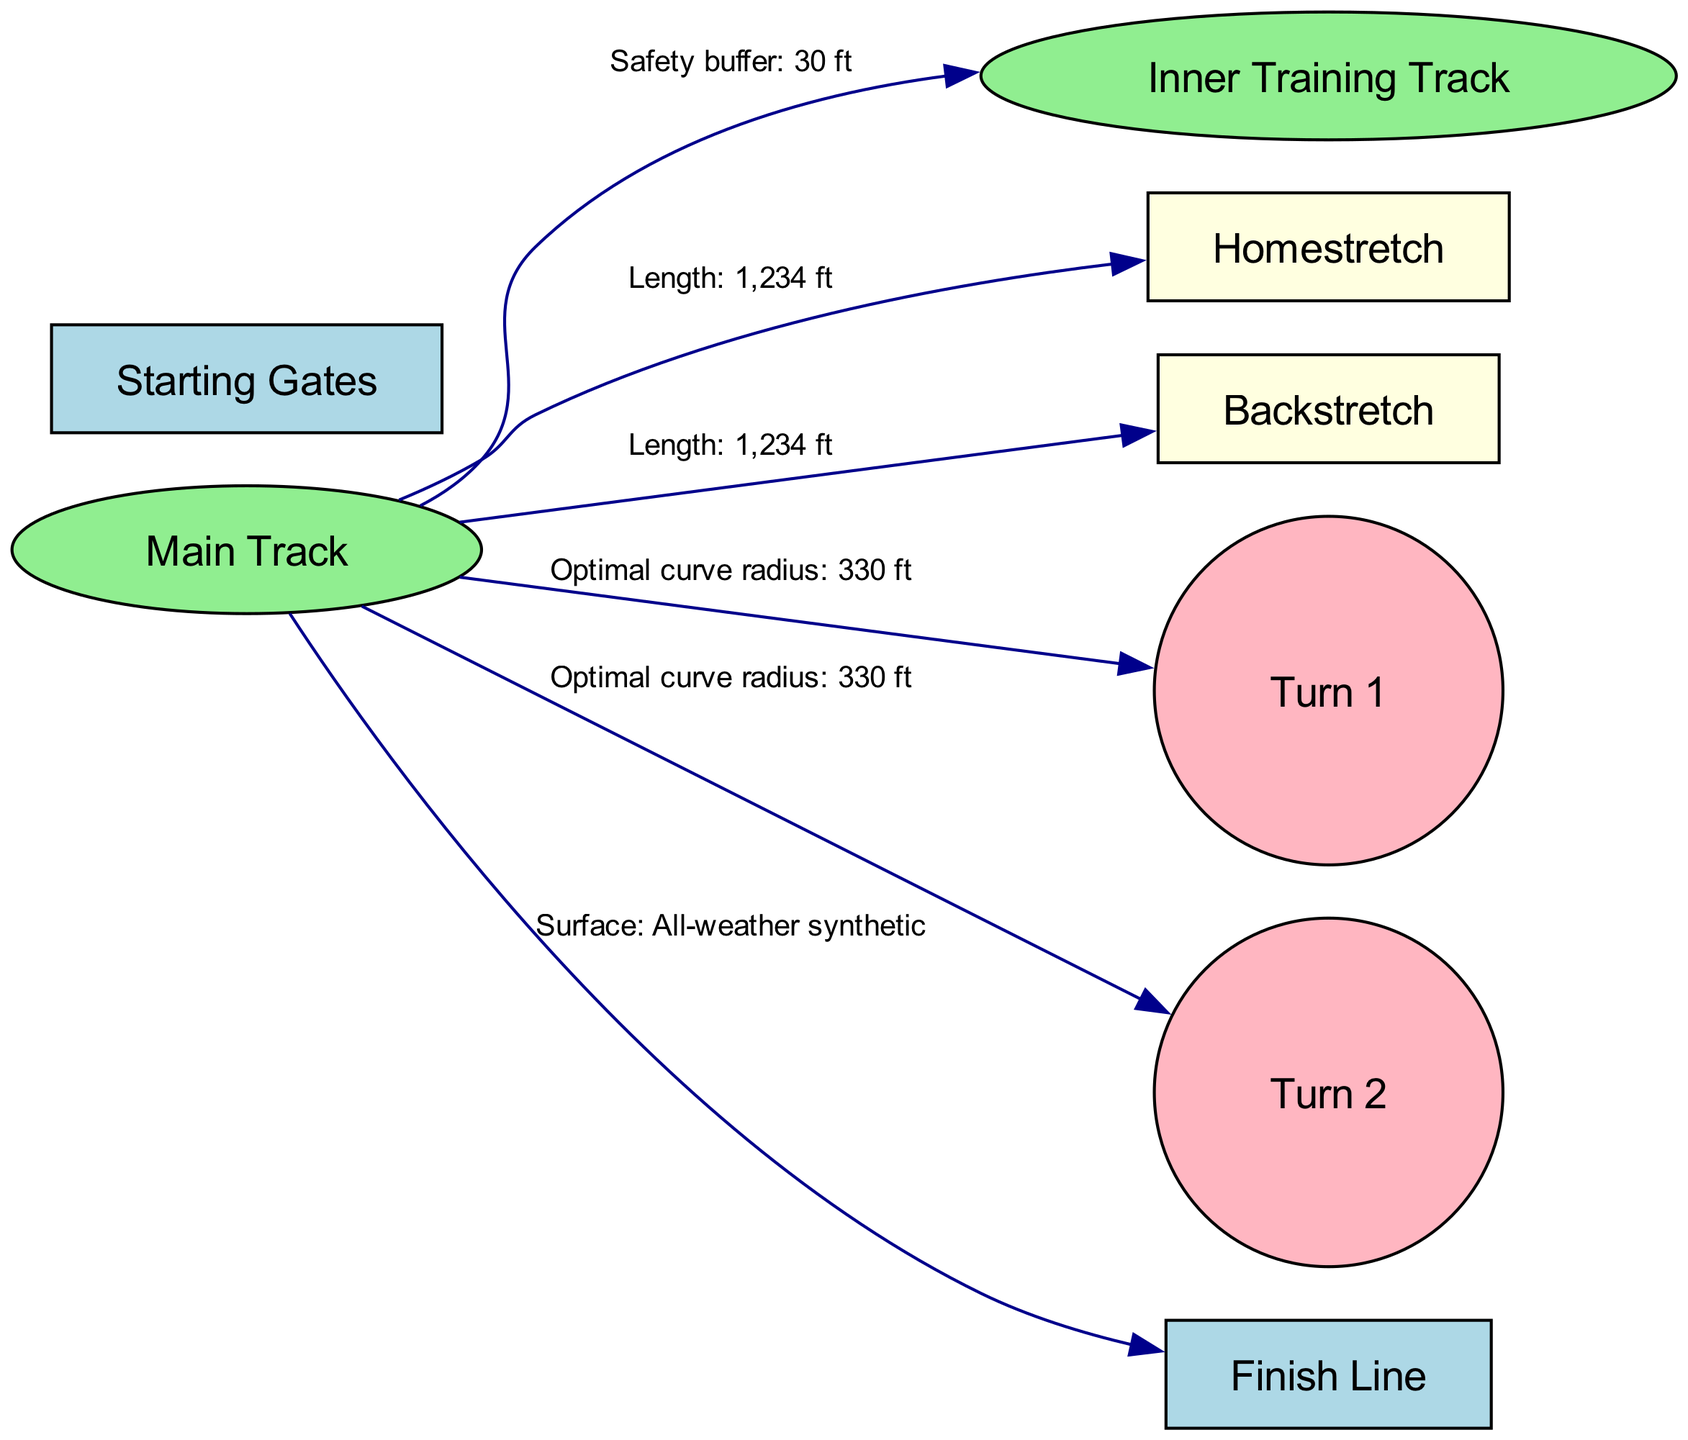What is the optimal curve radius for Turn 1? According to the edge connecting the Main Track to Turn 1, the optimal curve radius is stated as 330 ft.
Answer: 330 ft What is the surface composition of the main track? The edge connecting the Main Track to the Finish Line indicates that the surface composition is "All-weather synthetic".
Answer: All-weather synthetic How many nodes are present in the diagram? The diagram lists a total of 8 distinct nodes, which represent different parts of the race track configuration.
Answer: 8 What connects the Main Track to the Backstretch? The edge between the Main Track and the Backstretch states the length is 1,234 ft, signifying their direct connection.
Answer: Length: 1,234 ft What is the safety buffer from the Main Track to the Inner Training Track? The edge linking the Main Track to the Inner Training Track specifies a "Safety buffer: 30 ft", indicating the distance separating the two.
Answer: Safety buffer: 30 ft What is the length of the Homestretch? In the diagram, the relationship from the Main Track to the Homestretch mentions the length as 1,234 ft.
Answer: 1,234 ft What type of node is the Inner Training Track represented as? The Inner Training Track is classified as an ellipse in the diagram based on its visual representation and label.
Answer: ellipse How does the optimal curve radius of Turn 2 compare to Turn 1? Both Turn 1 and Turn 2 have the same optimal curve radius of 330 ft, thus indicating they are designed similarly in this aspect.
Answer: 330 ft Which node does the Backstretch connect to? The Backstretch has a direct connection to the Main Track, as indicated by the edge specified in the diagram.
Answer: Main Track 